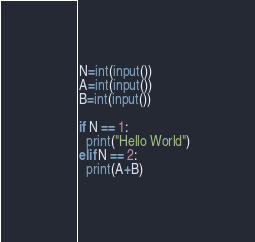Convert code to text. <code><loc_0><loc_0><loc_500><loc_500><_Python_>N=int(input())
A=int(input())
B=int(input())

if N == 1:
  print("Hello World")
elif N == 2:
  print(A+B)</code> 